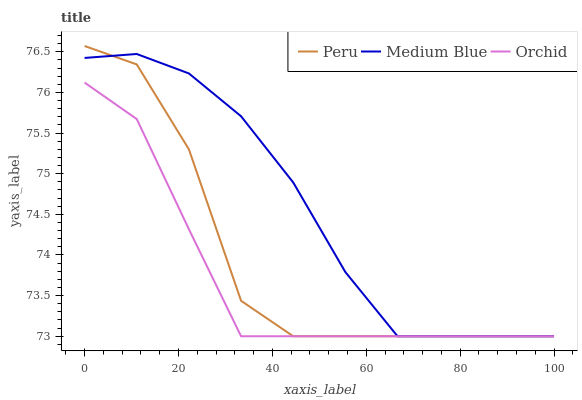Does Orchid have the minimum area under the curve?
Answer yes or no. Yes. Does Medium Blue have the maximum area under the curve?
Answer yes or no. Yes. Does Peru have the minimum area under the curve?
Answer yes or no. No. Does Peru have the maximum area under the curve?
Answer yes or no. No. Is Medium Blue the smoothest?
Answer yes or no. Yes. Is Peru the roughest?
Answer yes or no. Yes. Is Orchid the smoothest?
Answer yes or no. No. Is Orchid the roughest?
Answer yes or no. No. Does Medium Blue have the lowest value?
Answer yes or no. Yes. Does Peru have the highest value?
Answer yes or no. Yes. Does Orchid have the highest value?
Answer yes or no. No. Does Medium Blue intersect Orchid?
Answer yes or no. Yes. Is Medium Blue less than Orchid?
Answer yes or no. No. Is Medium Blue greater than Orchid?
Answer yes or no. No. 